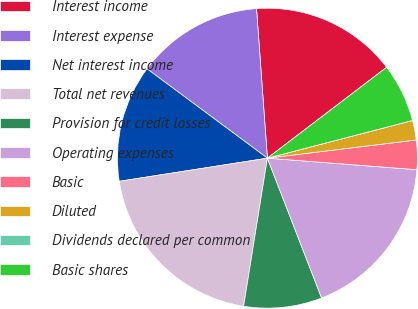Convert chart. <chart><loc_0><loc_0><loc_500><loc_500><pie_chart><fcel>Interest income<fcel>Interest expense<fcel>Net interest income<fcel>Total net revenues<fcel>Provision for credit losses<fcel>Operating expenses<fcel>Basic<fcel>Diluted<fcel>Dividends declared per common<fcel>Basic shares<nl><fcel>15.79%<fcel>13.68%<fcel>12.63%<fcel>20.0%<fcel>8.42%<fcel>17.89%<fcel>3.16%<fcel>2.11%<fcel>0.0%<fcel>6.32%<nl></chart> 